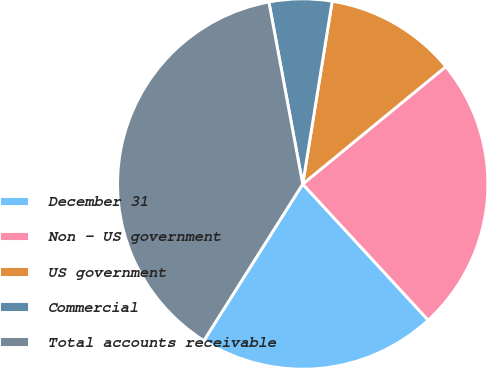Convert chart. <chart><loc_0><loc_0><loc_500><loc_500><pie_chart><fcel>December 31<fcel>Non - US government<fcel>US government<fcel>Commercial<fcel>Total accounts receivable<nl><fcel>20.82%<fcel>24.08%<fcel>11.52%<fcel>5.47%<fcel>38.11%<nl></chart> 